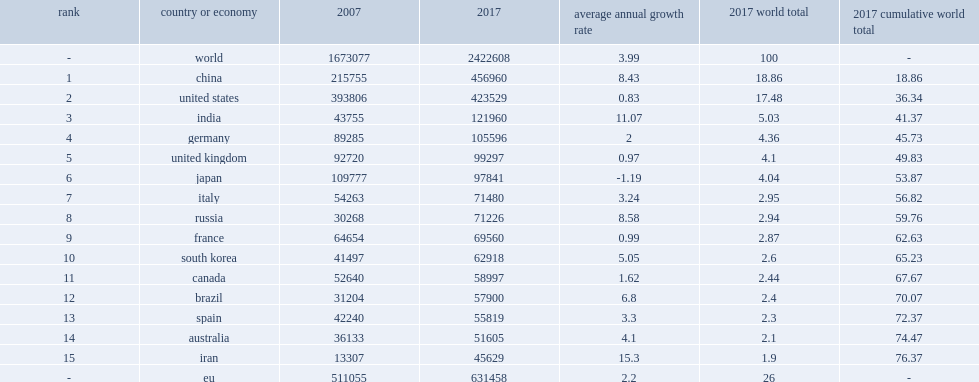How many articles do worldwide s&e publication output continue to grow in 2017? 2422608.0. In 2017, the united states were the world's largest producers of s&e publication output,how many million people produced of the 2.4 million world total? 423529.0. In 2017, china was the world's largest producers of s&e publication output,how many million people produced of the 2.4 million world total? 456960.0. 